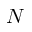<formula> <loc_0><loc_0><loc_500><loc_500>N</formula> 